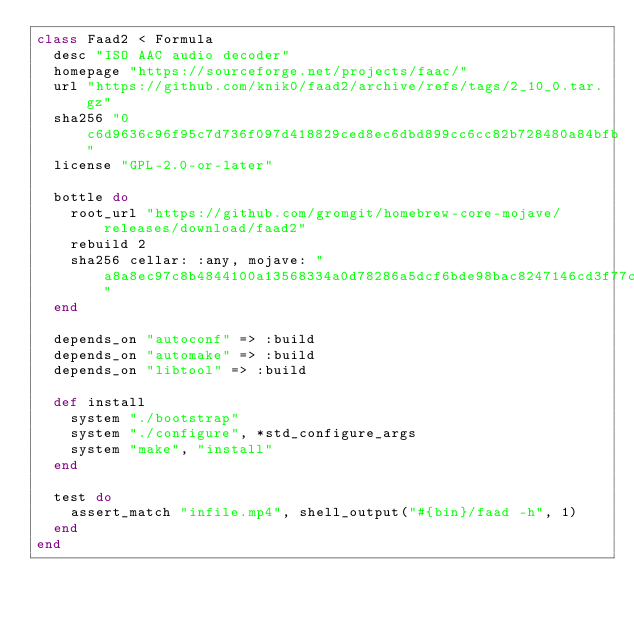Convert code to text. <code><loc_0><loc_0><loc_500><loc_500><_Ruby_>class Faad2 < Formula
  desc "ISO AAC audio decoder"
  homepage "https://sourceforge.net/projects/faac/"
  url "https://github.com/knik0/faad2/archive/refs/tags/2_10_0.tar.gz"
  sha256 "0c6d9636c96f95c7d736f097d418829ced8ec6dbd899cc6cc82b728480a84bfb"
  license "GPL-2.0-or-later"

  bottle do
    root_url "https://github.com/gromgit/homebrew-core-mojave/releases/download/faad2"
    rebuild 2
    sha256 cellar: :any, mojave: "a8a8ec97c8b4844100a13568334a0d78286a5dcf6bde98bac8247146cd3f77c3"
  end

  depends_on "autoconf" => :build
  depends_on "automake" => :build
  depends_on "libtool" => :build

  def install
    system "./bootstrap"
    system "./configure", *std_configure_args
    system "make", "install"
  end

  test do
    assert_match "infile.mp4", shell_output("#{bin}/faad -h", 1)
  end
end
</code> 